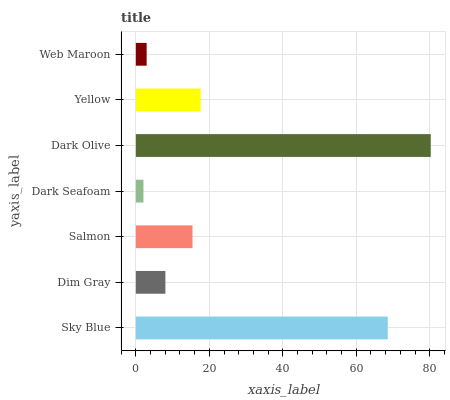Is Dark Seafoam the minimum?
Answer yes or no. Yes. Is Dark Olive the maximum?
Answer yes or no. Yes. Is Dim Gray the minimum?
Answer yes or no. No. Is Dim Gray the maximum?
Answer yes or no. No. Is Sky Blue greater than Dim Gray?
Answer yes or no. Yes. Is Dim Gray less than Sky Blue?
Answer yes or no. Yes. Is Dim Gray greater than Sky Blue?
Answer yes or no. No. Is Sky Blue less than Dim Gray?
Answer yes or no. No. Is Salmon the high median?
Answer yes or no. Yes. Is Salmon the low median?
Answer yes or no. Yes. Is Web Maroon the high median?
Answer yes or no. No. Is Dark Seafoam the low median?
Answer yes or no. No. 